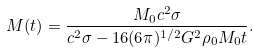Convert formula to latex. <formula><loc_0><loc_0><loc_500><loc_500>M ( t ) = \frac { M _ { 0 } c ^ { 2 } \sigma } { c ^ { 2 } \sigma - 1 6 ( 6 \pi ) ^ { 1 / 2 } G ^ { 2 } \rho _ { 0 } M _ { 0 } t } .</formula> 